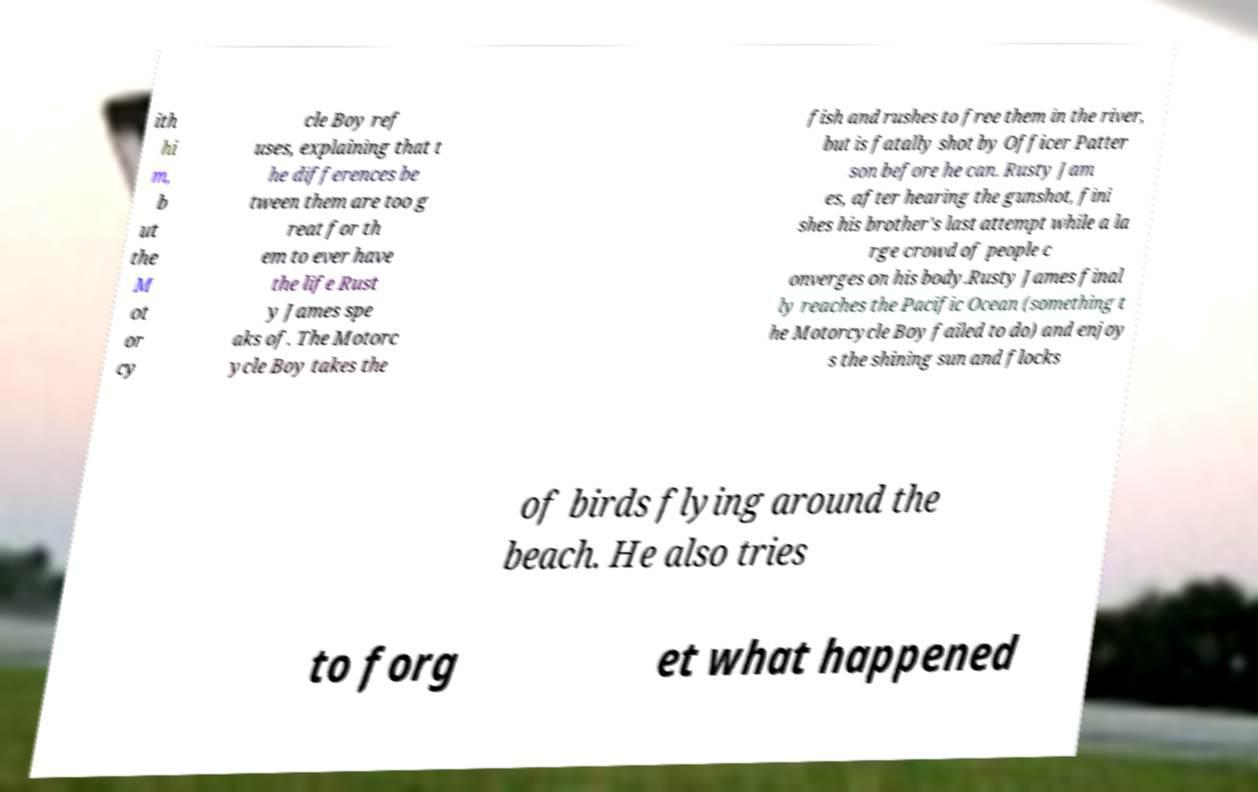Could you assist in decoding the text presented in this image and type it out clearly? ith hi m, b ut the M ot or cy cle Boy ref uses, explaining that t he differences be tween them are too g reat for th em to ever have the life Rust y James spe aks of. The Motorc ycle Boy takes the fish and rushes to free them in the river, but is fatally shot by Officer Patter son before he can. Rusty Jam es, after hearing the gunshot, fini shes his brother's last attempt while a la rge crowd of people c onverges on his body.Rusty James final ly reaches the Pacific Ocean (something t he Motorcycle Boy failed to do) and enjoy s the shining sun and flocks of birds flying around the beach. He also tries to forg et what happened 